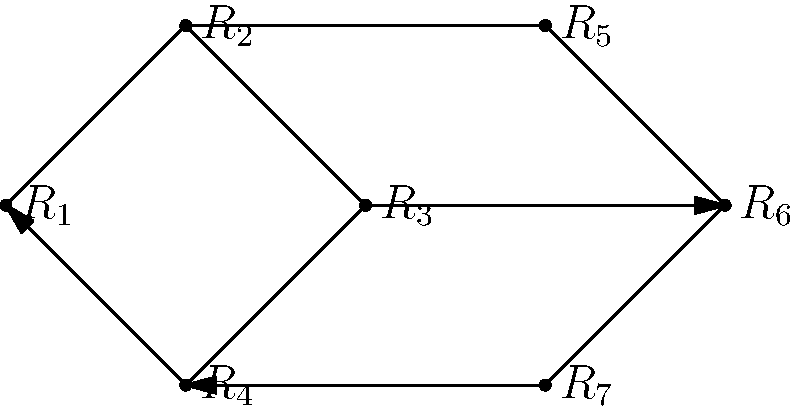Given the graph representing the connectivity of different brain regions, where each vertex $R_i$ represents a distinct region and directed edges indicate information flow, determine the minimum number of regions that need to be removed to disconnect region $R_1$ from region $R_7$. How does this relate to the concept of network resilience in neuroscience? To solve this problem, we need to follow these steps:

1. Identify all possible paths from $R_1$ to $R_7$:
   Path 1: $R_1 \rightarrow R_2 \rightarrow R_5 \rightarrow R_6 \rightarrow R_7$
   Path 2: $R_1 \rightarrow R_2 \rightarrow R_3 \rightarrow R_6 \rightarrow R_7$
   Path 3: $R_1 \rightarrow R_4 \rightarrow R_7$

2. Determine the minimum number of regions to remove:
   - Removing $R_2$ and $R_4$ would disconnect all paths from $R_1$ to $R_7$.
   - This is the minimum number of regions needed, as removing any single region would still leave at least one path intact.

3. Relation to network resilience in neuroscience:
   - Network resilience refers to the brain's ability to maintain functionality despite damage or disruption to certain regions.
   - In this case, the presence of multiple paths between $R_1$ and $R_7$ demonstrates resilience, as information can still flow even if one path is disrupted.
   - The need to remove two regions to completely disconnect $R_1$ from $R_7$ indicates a moderate level of resilience in this network.
   - This concept is crucial in understanding how the brain maintains cognitive functions in the face of localized damage or degenerative diseases.

4. Implications for a psychiatrist:
   - Understanding network resilience can inform treatment strategies for patients with brain injuries or neurodegenerative disorders.
   - It can help in predicting the potential impact of localized brain damage on overall cognitive function.
   - This knowledge can guide the development of interventions aimed at strengthening alternative neural pathways to compensate for damaged regions.
Answer: 2 regions; moderate resilience 